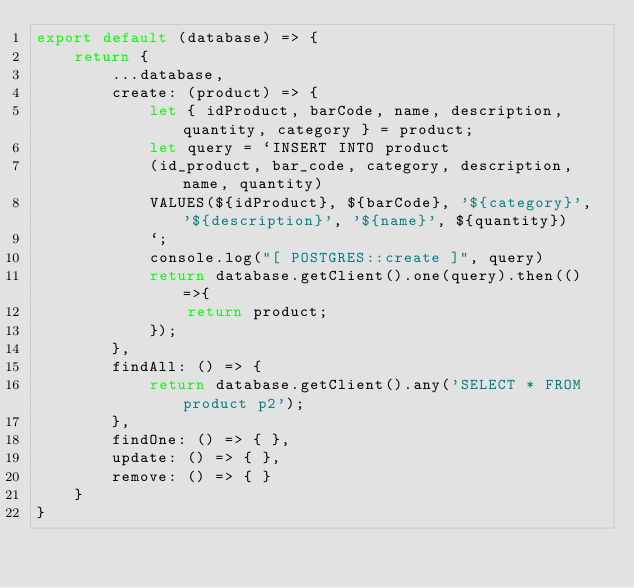Convert code to text. <code><loc_0><loc_0><loc_500><loc_500><_JavaScript_>export default (database) => {
    return {
        ...database,
        create: (product) => {
            let { idProduct, barCode, name, description, quantity, category } = product;
            let query = `INSERT INTO product
            (id_product, bar_code, category, description, name, quantity) 
            VALUES(${idProduct}, ${barCode}, '${category}', '${description}', '${name}', ${quantity})
            `;
            console.log("[ POSTGRES::create ]", query)
            return database.getClient().one(query).then(()=>{
                return product;
            });
        },
        findAll: () => {
            return database.getClient().any('SELECT * FROM product p2');
        },
        findOne: () => { },
        update: () => { },
        remove: () => { }
    }
}
</code> 